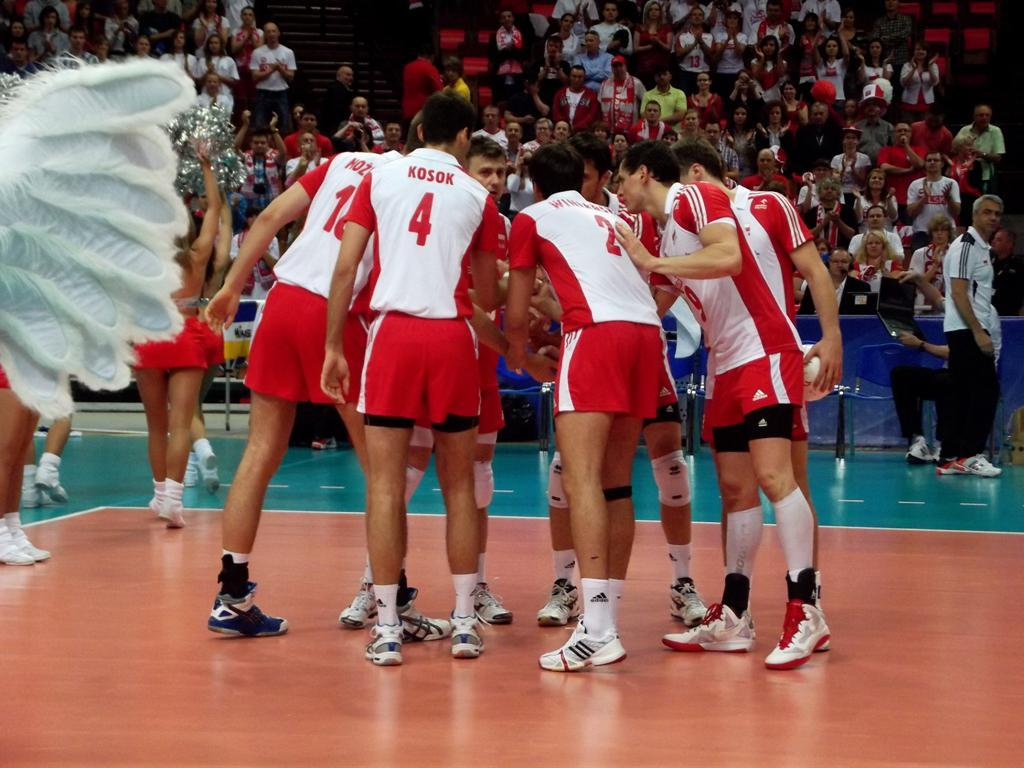<image>
Provide a brief description of the given image. Player Kosok is number 4 and is in a huddle with his team. 